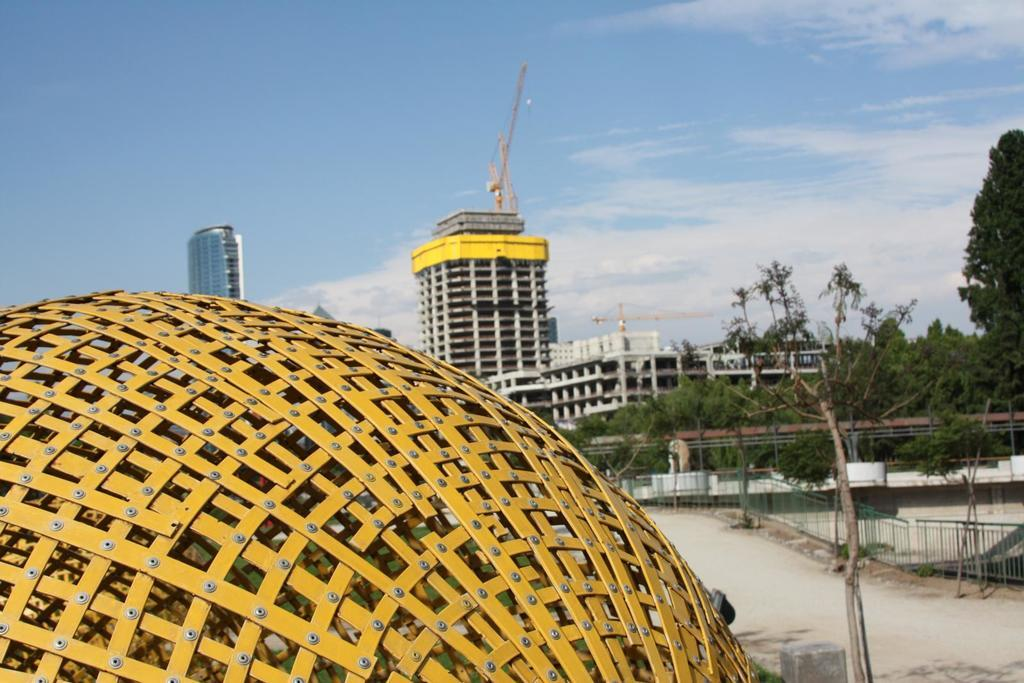What type of structure can be seen in the image? There is a fence in the image. What else can be seen in the image besides the fence? There is a road, trees, a building, and the sky visible in the image. Can you describe the road in the image? The road is visible in the image. What is the color of the sky in the image? The sky is visible at the top of the image. What type of wax ornament is hanging from the tree in the image? There is no wax ornament present in the image; it only features a fence, road, trees, a building, and the sky. 